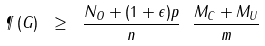<formula> <loc_0><loc_0><loc_500><loc_500>\P \left ( G \right ) \ \geq \ \frac { N _ { O } + ( 1 + \epsilon ) p } { n } \ \frac { M _ { C } + M _ { U } } { m }</formula> 